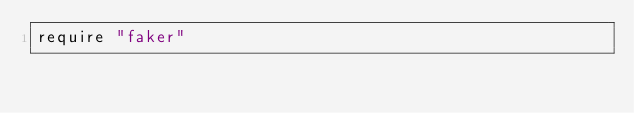<code> <loc_0><loc_0><loc_500><loc_500><_Ruby_>require "faker"
</code> 